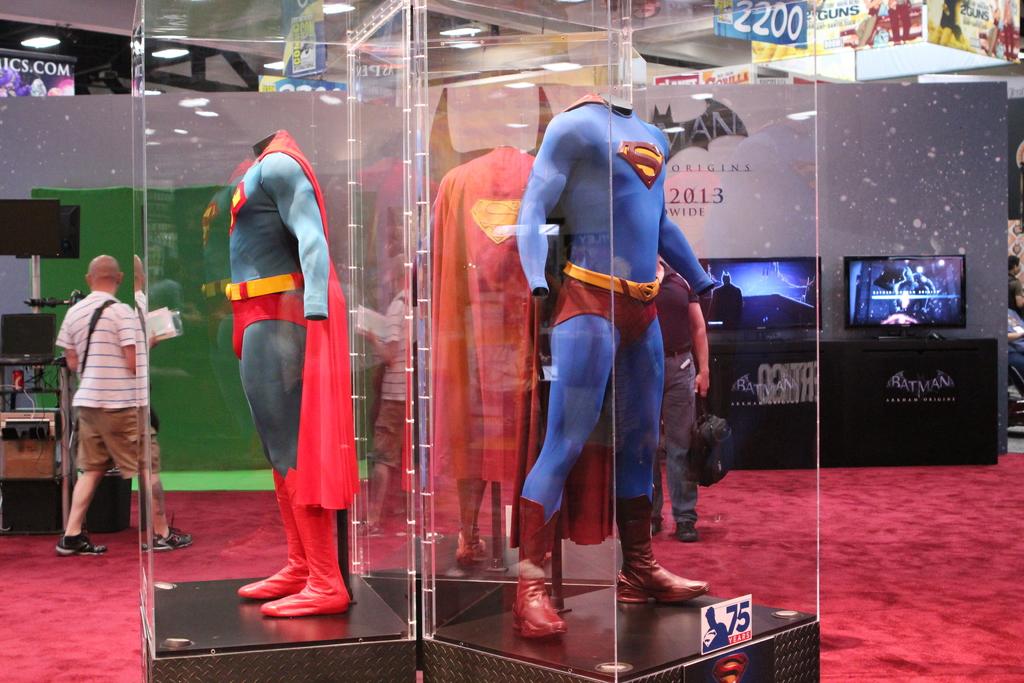How many years is written on the display of superman?
Give a very brief answer. 75. What comic book character is the booth on the far right advertising?
Provide a succinct answer. Batman. 